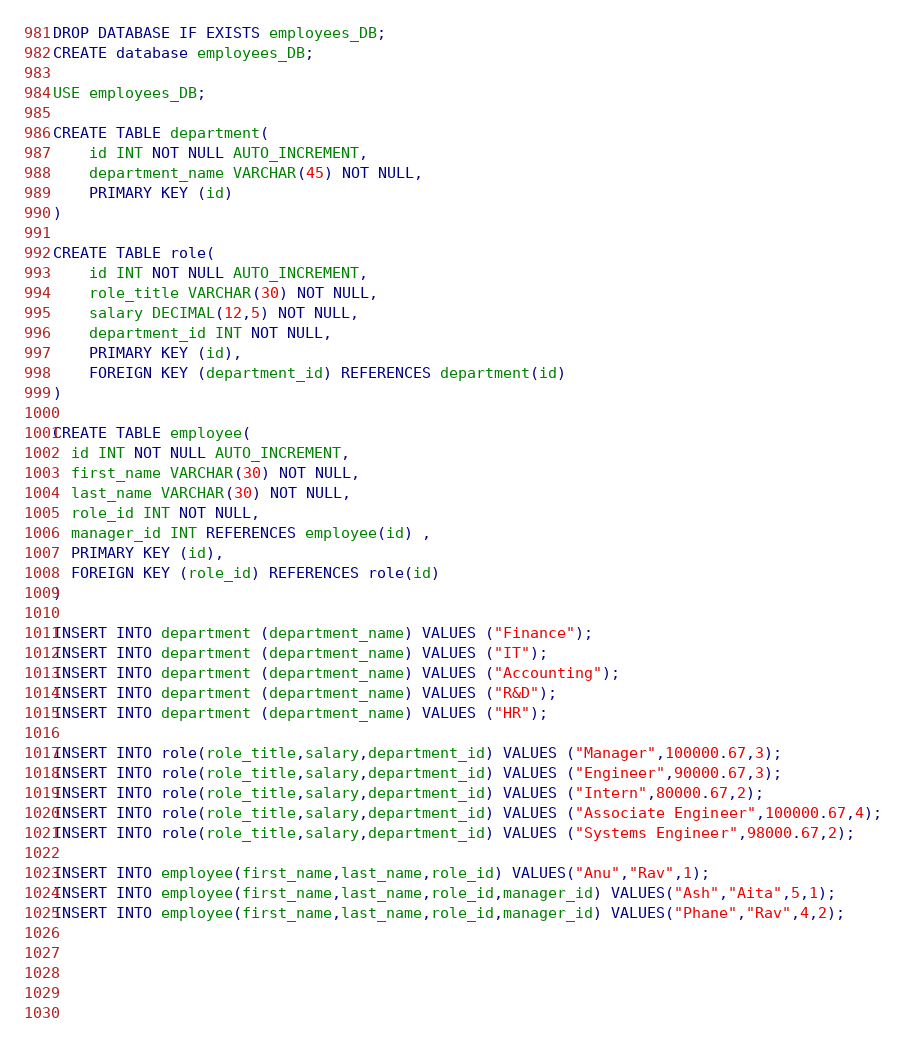<code> <loc_0><loc_0><loc_500><loc_500><_SQL_>DROP DATABASE IF EXISTS employees_DB;
CREATE database employees_DB;

USE employees_DB;

CREATE TABLE department(
    id INT NOT NULL AUTO_INCREMENT,
    department_name VARCHAR(45) NOT NULL,
    PRIMARY KEY (id)
)

CREATE TABLE role(
    id INT NOT NULL AUTO_INCREMENT,
    role_title VARCHAR(30) NOT NULL,
    salary DECIMAL(12,5) NOT NULL,
    department_id INT NOT NULL,
    PRIMARY KEY (id),
    FOREIGN KEY (department_id) REFERENCES department(id)
)

CREATE TABLE employee(
  id INT NOT NULL AUTO_INCREMENT,  
  first_name VARCHAR(30) NOT NULL,
  last_name VARCHAR(30) NOT NULL,
  role_id INT NOT NULL,
  manager_id INT REFERENCES employee(id) ,
  PRIMARY KEY (id),
  FOREIGN KEY (role_id) REFERENCES role(id)
)

INSERT INTO department (department_name) VALUES ("Finance");
INSERT INTO department (department_name) VALUES ("IT");
INSERT INTO department (department_name) VALUES ("Accounting");
INSERT INTO department (department_name) VALUES ("R&D");
INSERT INTO department (department_name) VALUES ("HR");

INSERT INTO role(role_title,salary,department_id) VALUES ("Manager",100000.67,3);
INSERT INTO role(role_title,salary,department_id) VALUES ("Engineer",90000.67,3);
INSERT INTO role(role_title,salary,department_id) VALUES ("Intern",80000.67,2);
INSERT INTO role(role_title,salary,department_id) VALUES ("Associate Engineer",100000.67,4);
INSERT INTO role(role_title,salary,department_id) VALUES ("Systems Engineer",98000.67,2);

INSERT INTO employee(first_name,last_name,role_id) VALUES("Anu","Rav",1);
INSERT INTO employee(first_name,last_name,role_id,manager_id) VALUES("Ash","Aita",5,1);
INSERT INTO employee(first_name,last_name,role_id,manager_id) VALUES("Phane","Rav",4,2);




 
</code> 